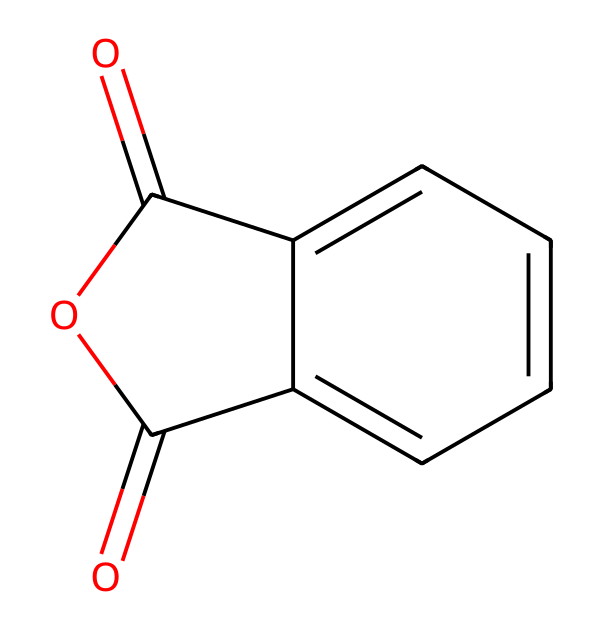How many carbon atoms are in phthalic anhydride? In the SMILES representation, "c2ccccc" indicates a benzene ring, which contains 6 carbon atoms. The rest of the structure includes 4 additional carbon atoms from "O=C1OC(=O)". Adding them together gives 8 carbon atoms.
Answer: 8 What is the total number of oxygen atoms in phthalic anhydride? The SMILES shows "O=C" twice, indicating 2 oxygen atoms in carbonyls, and an additional "O" for the cyclic anhydride structure. Therefore, there are a total of 3 oxygen atoms.
Answer: 3 Does phthalic anhydride contain any double bonds? The "C=O" segments in the SMILES indicate double bonds between carbon and oxygen in the carbonyl functional groups.
Answer: yes What type of chemical structure is phthalic anhydride classified under? The presence of the anhydride structure, which typically includes two acyl groups joined through an oxygen atom, identifies the compound as an acid anhydride.
Answer: acid anhydride How many rings are present in the structure of phthalic anhydride? Analyzing the SMILES indicates a cyclical structure formed by "C1OC(=O)", which includes one ring structure.
Answer: 1 What functional groups are present in phthalic anhydride? Phthalic anhydride contains two carbonyl (C=O) groups and an anhydride functional group defined by its cyclic nature.
Answer: anhydride and carbonyl What is the molecular formula of phthalic anhydride? The total count of carbon (8), hydrogen (4), and oxygen (3) from analyzing the structure leads to the molecular formula C8H4O3.
Answer: C8H4O3 